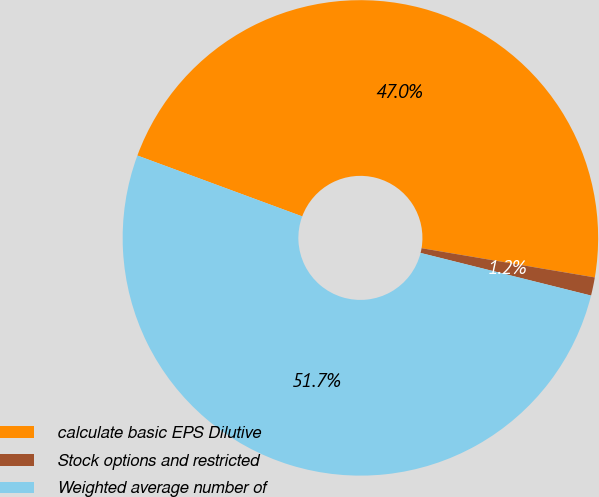Convert chart. <chart><loc_0><loc_0><loc_500><loc_500><pie_chart><fcel>calculate basic EPS Dilutive<fcel>Stock options and restricted<fcel>Weighted average number of<nl><fcel>47.03%<fcel>1.24%<fcel>51.73%<nl></chart> 